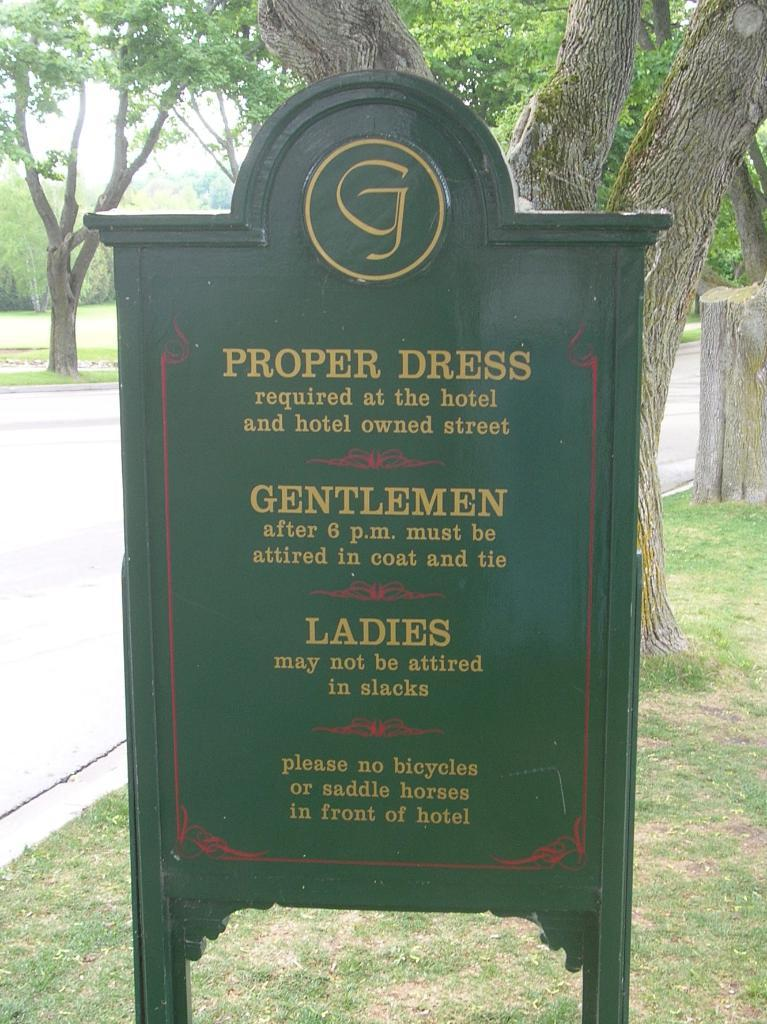What is the main object in the image? There is a name board in the image. What can be found on the name board? There is text on the name board. What type of natural scenery is visible behind the name board? Trees are visible behind the name board. What else can be seen on the left side of the image? A road is visible on the left side of the image. How many boys are playing in the position shown in the image? There are no boys or any indication of a game or position in the image. The image features a name board with text, trees, and a road. 